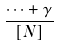Convert formula to latex. <formula><loc_0><loc_0><loc_500><loc_500>\frac { \cdots + \gamma } { \left [ N \right ] }</formula> 